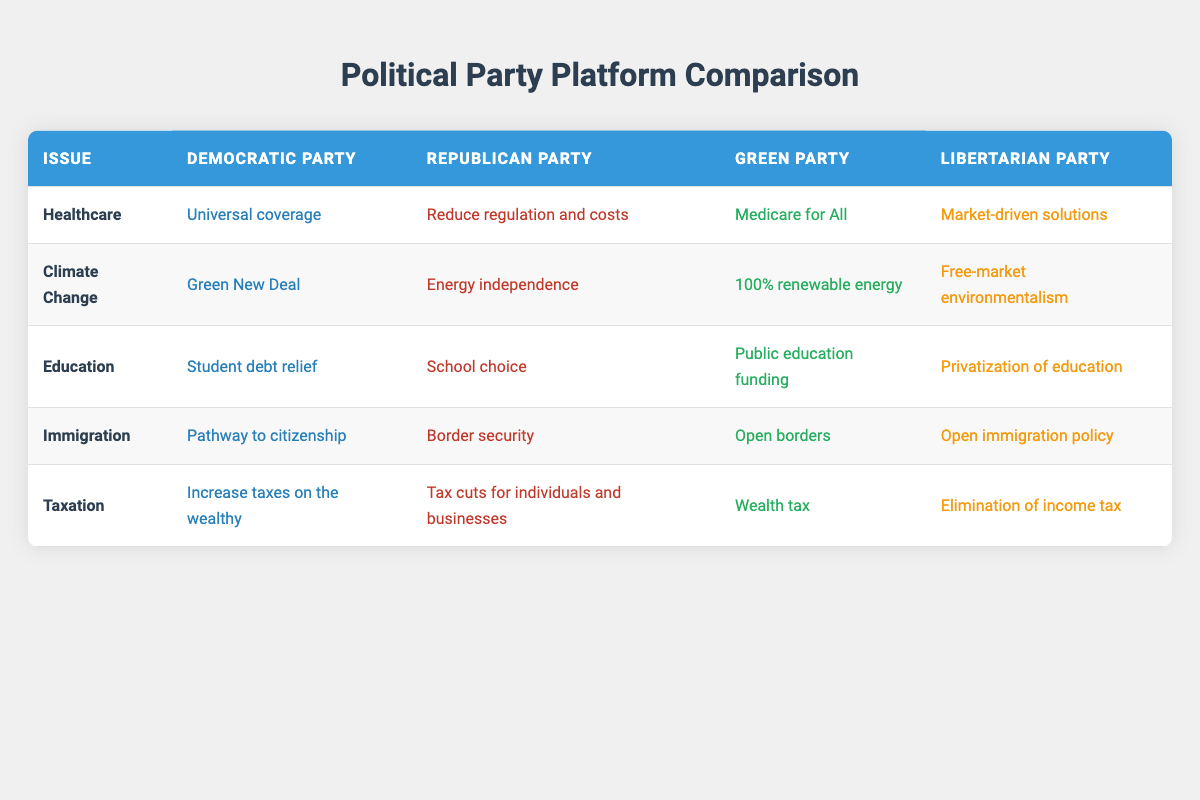What is the focus of the Republican Party on healthcare? The table lists the Republican Party's priority for healthcare as "Reduce regulation and costs." This is directly taken from the relevant cell in the row for healthcare and the column for the Republican Party.
Answer: Reduce regulation and costs Which party focuses on the Green New Deal? The healthcare issue is addressed in the table under the climate change row, where the Democratic Party's priority is listed as "Green New Deal." This is confirmed by the information in the respective row and column.
Answer: Democratic Party Is the Libertarian Party in favor of open borders regarding immigration? The information from the table indicates that the Libertarian Party's focus on immigration is "Open immigration policy." Therefore, the answer to the question is derived from the column for Libertarian Party in the row for immigration.
Answer: Yes What are the taxation priorities of the Green Party and the Democratic Party? Looking at the taxation row, the Green Party's focus is on "Wealth tax" while the Democratic Party's focus is "Increase taxes on the wealthy." Both values can be found in their respective columns within the taxation row.
Answer: Wealth tax; Increase taxes on the wealthy Which party has a priority for school choice in education? From the education row in the table, it is evident that the Republican Party emphasizes "School choice." This information is accessible directly from the table without further calculations.
Answer: Republican Party How many parties support open immigration policies? The table indicates that both the Green Party and the Libertarian Party prioritize open immigration policies, which can be verified by looking at their respective rows for immigration in the table. Therefore, we count the number of parties that align with this position.
Answer: 2 What is the difference in healthcare focus between the Democratic Party and the Republican Party? The table shows the Democratic Party's focus on healthcare as "Universal coverage" and the Republican Party's focus as "Reduce regulation and costs." The difference lies in the approach: one advocates for universal coverage while the other aims to reduce costs. Therefore, the comparison reveals the divergence in principles.
Answer: Universal coverage vs. Reduce regulation and costs Which party's climate change priority emphasizes free-market solutions? According to the climate change row in the table, the Libertarian Party’s focus is "Free-market environmentalism," making them the party prioritizing free-market solutions in this context. This can be checked by referencing the respective column.
Answer: Libertarian Party What is the commonality in immigration policies between the Green Party and the Libertarian Party? Reviewing the table, both parties support policies that can be interpreted as open or unrestricted immigration since the Green Party emphasizes "Open borders" while the Libertarian Party specifies "Open immigration policy." The similarity can thus be confirmed by comparing their respective immigration priorities.
Answer: Both support open immigration policies 